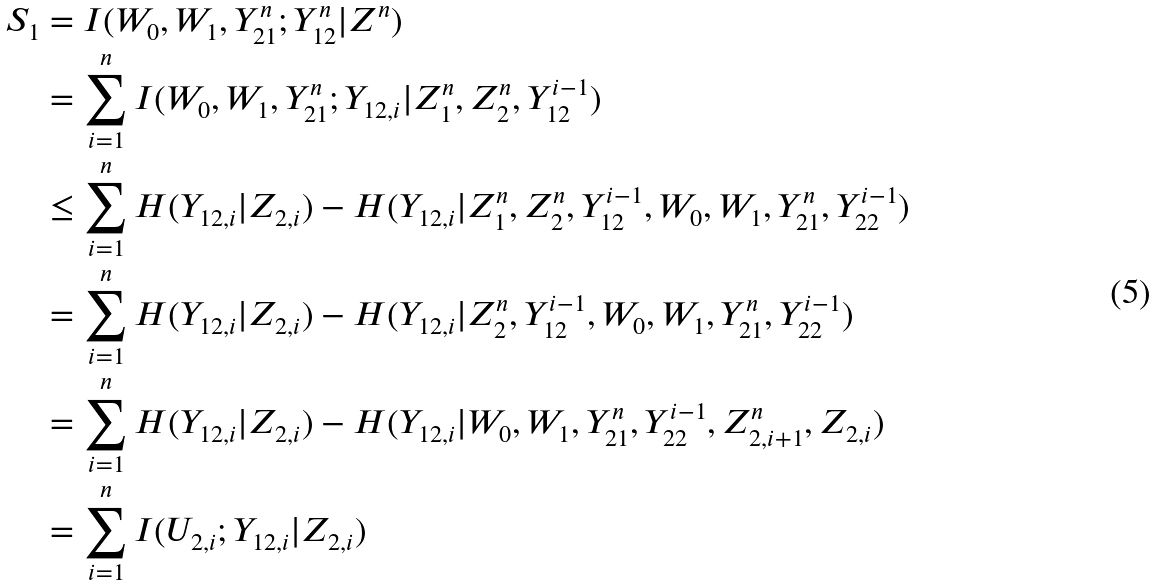<formula> <loc_0><loc_0><loc_500><loc_500>S _ { 1 } & = I ( W _ { 0 } , W _ { 1 } , Y _ { 2 1 } ^ { n } ; Y _ { 1 2 } ^ { n } | Z ^ { n } ) \\ & = \sum _ { i = 1 } ^ { n } I ( W _ { 0 } , W _ { 1 } , Y _ { 2 1 } ^ { n } ; Y _ { 1 2 , i } | Z _ { 1 } ^ { n } , Z _ { 2 } ^ { n } , Y _ { 1 2 } ^ { i - 1 } ) \\ & \leq \sum _ { i = 1 } ^ { n } H ( Y _ { 1 2 , i } | Z _ { 2 , i } ) - H ( Y _ { 1 2 , i } | Z _ { 1 } ^ { n } , Z _ { 2 } ^ { n } , Y _ { 1 2 } ^ { i - 1 } , W _ { 0 } , W _ { 1 } , Y _ { 2 1 } ^ { n } , Y _ { 2 2 } ^ { i - 1 } ) \\ & = \sum _ { i = 1 } ^ { n } H ( Y _ { 1 2 , i } | Z _ { 2 , i } ) - H ( Y _ { 1 2 , i } | Z _ { 2 } ^ { n } , Y _ { 1 2 } ^ { i - 1 } , W _ { 0 } , W _ { 1 } , Y _ { 2 1 } ^ { n } , Y _ { 2 2 } ^ { i - 1 } ) \\ & = \sum _ { i = 1 } ^ { n } H ( Y _ { 1 2 , i } | Z _ { 2 , i } ) - H ( Y _ { 1 2 , i } | W _ { 0 } , W _ { 1 } , Y _ { 2 1 } ^ { n } , Y _ { 2 2 } ^ { i - 1 } , Z _ { 2 , i + 1 } ^ { n } , Z _ { 2 , i } ) \\ & = \sum _ { i = 1 } ^ { n } I ( U _ { 2 , i } ; Y _ { 1 2 , i } | Z _ { 2 , i } )</formula> 